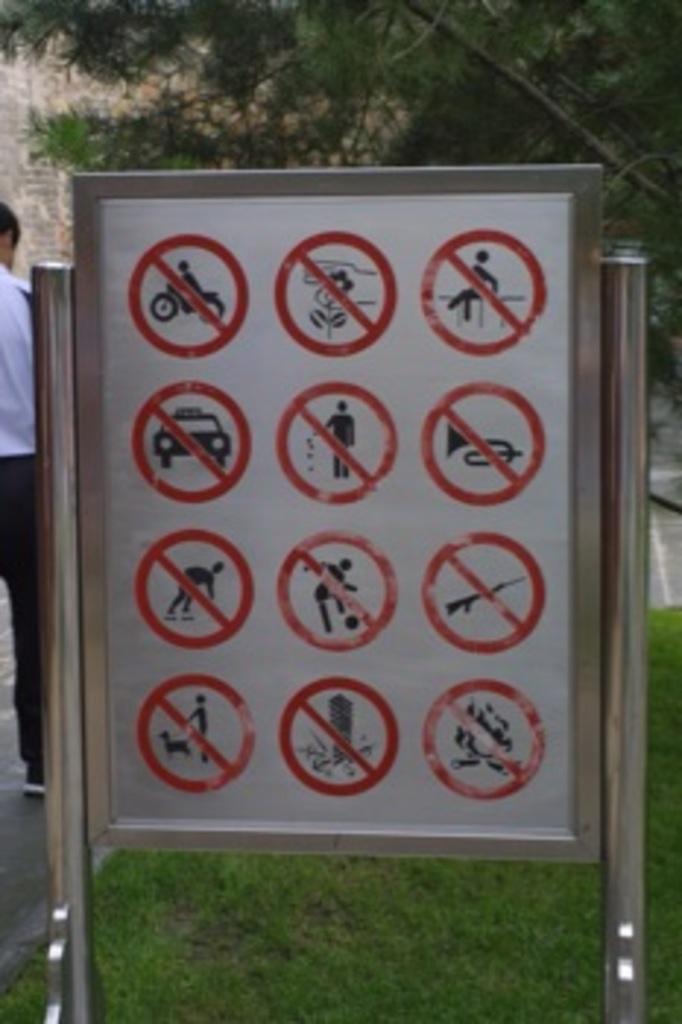Please provide a concise description of this image. In the foreground of the picture there is a sign board. At the bottom there is grass. On the left there is a person standing, on the road. At the top there are trees and there is a brick wall. 